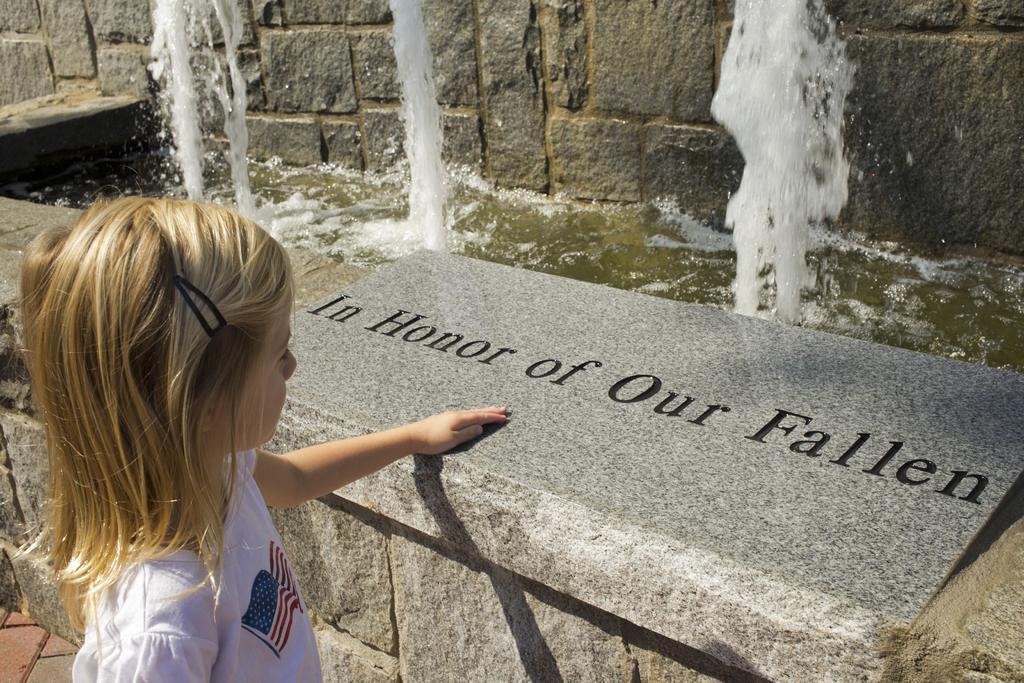Please provide a concise description of this image. In this image we can see a child. Near to the child there is a stone wall. On the wall there is text. In the back there is another stone wall. Also there is water. 